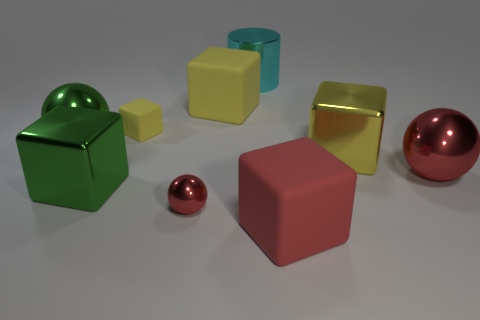How many yellow cubes must be subtracted to get 1 yellow cubes? 2 Subtract all green balls. How many balls are left? 2 Subtract all large yellow matte cubes. How many cubes are left? 4 Add 1 yellow things. How many objects exist? 10 Subtract 1 cylinders. How many cylinders are left? 0 Add 4 large metal cubes. How many large metal cubes exist? 6 Subtract 0 brown cubes. How many objects are left? 9 Subtract all balls. How many objects are left? 6 Subtract all blue cylinders. Subtract all cyan cubes. How many cylinders are left? 1 Subtract all cyan blocks. How many purple cylinders are left? 0 